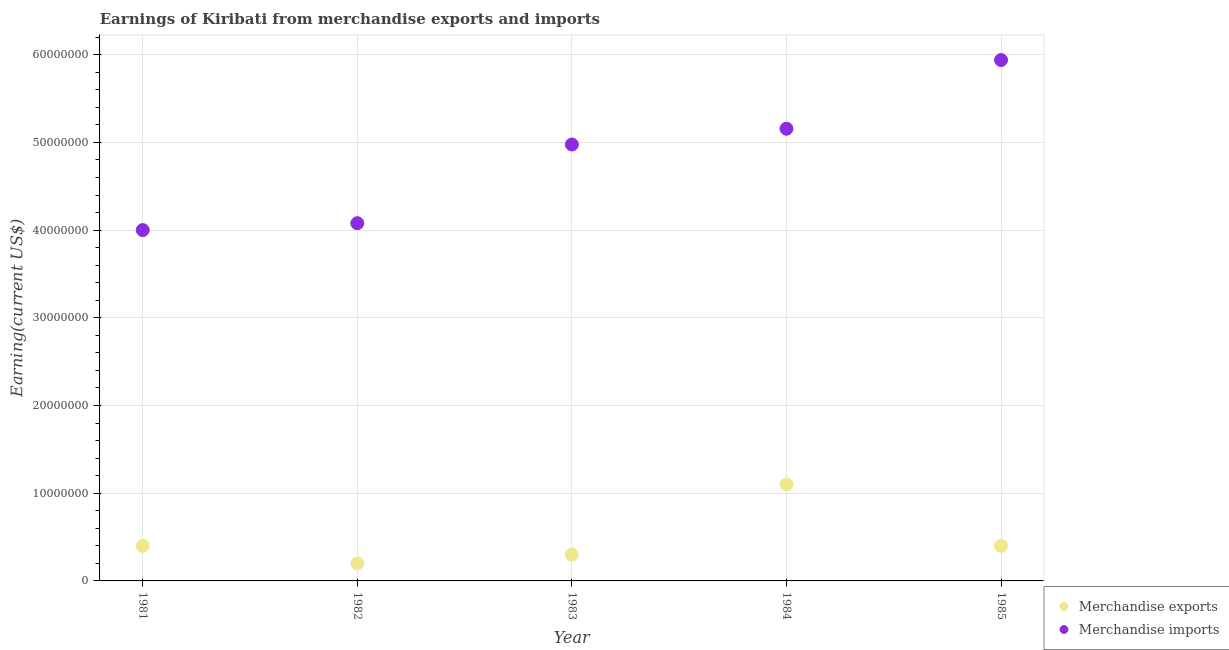How many different coloured dotlines are there?
Your answer should be very brief. 2. What is the earnings from merchandise exports in 1985?
Your answer should be compact. 4.00e+06. Across all years, what is the maximum earnings from merchandise imports?
Keep it short and to the point. 5.94e+07. Across all years, what is the minimum earnings from merchandise exports?
Offer a terse response. 2.00e+06. In which year was the earnings from merchandise exports maximum?
Make the answer very short. 1984. What is the total earnings from merchandise imports in the graph?
Provide a succinct answer. 2.41e+08. What is the difference between the earnings from merchandise imports in 1981 and that in 1983?
Make the answer very short. -9.76e+06. What is the difference between the earnings from merchandise imports in 1985 and the earnings from merchandise exports in 1983?
Offer a very short reply. 5.64e+07. What is the average earnings from merchandise imports per year?
Keep it short and to the point. 4.83e+07. In the year 1982, what is the difference between the earnings from merchandise exports and earnings from merchandise imports?
Your response must be concise. -3.88e+07. What is the ratio of the earnings from merchandise imports in 1981 to that in 1984?
Your answer should be very brief. 0.78. Is the earnings from merchandise exports in 1983 less than that in 1984?
Make the answer very short. Yes. What is the difference between the highest and the lowest earnings from merchandise imports?
Ensure brevity in your answer.  1.94e+07. Does the earnings from merchandise exports monotonically increase over the years?
Your response must be concise. No. Is the earnings from merchandise exports strictly greater than the earnings from merchandise imports over the years?
Offer a very short reply. No. How many dotlines are there?
Your answer should be compact. 2. Does the graph contain any zero values?
Provide a short and direct response. No. Does the graph contain grids?
Your answer should be compact. Yes. How many legend labels are there?
Give a very brief answer. 2. How are the legend labels stacked?
Provide a short and direct response. Vertical. What is the title of the graph?
Provide a short and direct response. Earnings of Kiribati from merchandise exports and imports. What is the label or title of the Y-axis?
Your answer should be compact. Earning(current US$). What is the Earning(current US$) in Merchandise imports in 1981?
Your answer should be compact. 4.00e+07. What is the Earning(current US$) in Merchandise imports in 1982?
Keep it short and to the point. 4.08e+07. What is the Earning(current US$) in Merchandise imports in 1983?
Your answer should be very brief. 4.98e+07. What is the Earning(current US$) in Merchandise exports in 1984?
Your response must be concise. 1.10e+07. What is the Earning(current US$) in Merchandise imports in 1984?
Your answer should be compact. 5.16e+07. What is the Earning(current US$) in Merchandise exports in 1985?
Offer a very short reply. 4.00e+06. What is the Earning(current US$) of Merchandise imports in 1985?
Ensure brevity in your answer.  5.94e+07. Across all years, what is the maximum Earning(current US$) of Merchandise exports?
Keep it short and to the point. 1.10e+07. Across all years, what is the maximum Earning(current US$) in Merchandise imports?
Give a very brief answer. 5.94e+07. Across all years, what is the minimum Earning(current US$) in Merchandise exports?
Your answer should be very brief. 2.00e+06. Across all years, what is the minimum Earning(current US$) in Merchandise imports?
Keep it short and to the point. 4.00e+07. What is the total Earning(current US$) of Merchandise exports in the graph?
Make the answer very short. 2.40e+07. What is the total Earning(current US$) in Merchandise imports in the graph?
Provide a short and direct response. 2.41e+08. What is the difference between the Earning(current US$) in Merchandise imports in 1981 and that in 1982?
Your response must be concise. -7.85e+05. What is the difference between the Earning(current US$) of Merchandise exports in 1981 and that in 1983?
Make the answer very short. 1.00e+06. What is the difference between the Earning(current US$) in Merchandise imports in 1981 and that in 1983?
Your response must be concise. -9.76e+06. What is the difference between the Earning(current US$) of Merchandise exports in 1981 and that in 1984?
Offer a terse response. -7.00e+06. What is the difference between the Earning(current US$) in Merchandise imports in 1981 and that in 1984?
Give a very brief answer. -1.16e+07. What is the difference between the Earning(current US$) in Merchandise imports in 1981 and that in 1985?
Your answer should be very brief. -1.94e+07. What is the difference between the Earning(current US$) of Merchandise imports in 1982 and that in 1983?
Provide a succinct answer. -8.97e+06. What is the difference between the Earning(current US$) in Merchandise exports in 1982 and that in 1984?
Your response must be concise. -9.00e+06. What is the difference between the Earning(current US$) in Merchandise imports in 1982 and that in 1984?
Your response must be concise. -1.08e+07. What is the difference between the Earning(current US$) of Merchandise exports in 1982 and that in 1985?
Keep it short and to the point. -2.00e+06. What is the difference between the Earning(current US$) in Merchandise imports in 1982 and that in 1985?
Your answer should be compact. -1.86e+07. What is the difference between the Earning(current US$) of Merchandise exports in 1983 and that in 1984?
Make the answer very short. -8.00e+06. What is the difference between the Earning(current US$) of Merchandise imports in 1983 and that in 1984?
Your answer should be compact. -1.80e+06. What is the difference between the Earning(current US$) of Merchandise exports in 1983 and that in 1985?
Offer a terse response. -1.00e+06. What is the difference between the Earning(current US$) of Merchandise imports in 1983 and that in 1985?
Your answer should be compact. -9.63e+06. What is the difference between the Earning(current US$) in Merchandise exports in 1984 and that in 1985?
Keep it short and to the point. 7.00e+06. What is the difference between the Earning(current US$) of Merchandise imports in 1984 and that in 1985?
Make the answer very short. -7.83e+06. What is the difference between the Earning(current US$) of Merchandise exports in 1981 and the Earning(current US$) of Merchandise imports in 1982?
Ensure brevity in your answer.  -3.68e+07. What is the difference between the Earning(current US$) of Merchandise exports in 1981 and the Earning(current US$) of Merchandise imports in 1983?
Make the answer very short. -4.58e+07. What is the difference between the Earning(current US$) in Merchandise exports in 1981 and the Earning(current US$) in Merchandise imports in 1984?
Your answer should be compact. -4.76e+07. What is the difference between the Earning(current US$) in Merchandise exports in 1981 and the Earning(current US$) in Merchandise imports in 1985?
Offer a very short reply. -5.54e+07. What is the difference between the Earning(current US$) in Merchandise exports in 1982 and the Earning(current US$) in Merchandise imports in 1983?
Give a very brief answer. -4.78e+07. What is the difference between the Earning(current US$) in Merchandise exports in 1982 and the Earning(current US$) in Merchandise imports in 1984?
Offer a terse response. -4.96e+07. What is the difference between the Earning(current US$) in Merchandise exports in 1982 and the Earning(current US$) in Merchandise imports in 1985?
Your response must be concise. -5.74e+07. What is the difference between the Earning(current US$) of Merchandise exports in 1983 and the Earning(current US$) of Merchandise imports in 1984?
Your response must be concise. -4.86e+07. What is the difference between the Earning(current US$) of Merchandise exports in 1983 and the Earning(current US$) of Merchandise imports in 1985?
Offer a very short reply. -5.64e+07. What is the difference between the Earning(current US$) in Merchandise exports in 1984 and the Earning(current US$) in Merchandise imports in 1985?
Your response must be concise. -4.84e+07. What is the average Earning(current US$) in Merchandise exports per year?
Ensure brevity in your answer.  4.80e+06. What is the average Earning(current US$) of Merchandise imports per year?
Your answer should be compact. 4.83e+07. In the year 1981, what is the difference between the Earning(current US$) in Merchandise exports and Earning(current US$) in Merchandise imports?
Provide a short and direct response. -3.60e+07. In the year 1982, what is the difference between the Earning(current US$) in Merchandise exports and Earning(current US$) in Merchandise imports?
Your answer should be compact. -3.88e+07. In the year 1983, what is the difference between the Earning(current US$) of Merchandise exports and Earning(current US$) of Merchandise imports?
Keep it short and to the point. -4.68e+07. In the year 1984, what is the difference between the Earning(current US$) of Merchandise exports and Earning(current US$) of Merchandise imports?
Make the answer very short. -4.06e+07. In the year 1985, what is the difference between the Earning(current US$) of Merchandise exports and Earning(current US$) of Merchandise imports?
Offer a very short reply. -5.54e+07. What is the ratio of the Earning(current US$) of Merchandise imports in 1981 to that in 1982?
Provide a succinct answer. 0.98. What is the ratio of the Earning(current US$) of Merchandise imports in 1981 to that in 1983?
Offer a very short reply. 0.8. What is the ratio of the Earning(current US$) of Merchandise exports in 1981 to that in 1984?
Keep it short and to the point. 0.36. What is the ratio of the Earning(current US$) in Merchandise imports in 1981 to that in 1984?
Your answer should be compact. 0.78. What is the ratio of the Earning(current US$) of Merchandise exports in 1981 to that in 1985?
Offer a very short reply. 1. What is the ratio of the Earning(current US$) of Merchandise imports in 1981 to that in 1985?
Your answer should be compact. 0.67. What is the ratio of the Earning(current US$) of Merchandise exports in 1982 to that in 1983?
Your response must be concise. 0.67. What is the ratio of the Earning(current US$) of Merchandise imports in 1982 to that in 1983?
Your answer should be very brief. 0.82. What is the ratio of the Earning(current US$) in Merchandise exports in 1982 to that in 1984?
Your response must be concise. 0.18. What is the ratio of the Earning(current US$) of Merchandise imports in 1982 to that in 1984?
Provide a short and direct response. 0.79. What is the ratio of the Earning(current US$) of Merchandise exports in 1982 to that in 1985?
Give a very brief answer. 0.5. What is the ratio of the Earning(current US$) of Merchandise imports in 1982 to that in 1985?
Keep it short and to the point. 0.69. What is the ratio of the Earning(current US$) of Merchandise exports in 1983 to that in 1984?
Keep it short and to the point. 0.27. What is the ratio of the Earning(current US$) of Merchandise imports in 1983 to that in 1984?
Offer a very short reply. 0.97. What is the ratio of the Earning(current US$) of Merchandise exports in 1983 to that in 1985?
Ensure brevity in your answer.  0.75. What is the ratio of the Earning(current US$) of Merchandise imports in 1983 to that in 1985?
Ensure brevity in your answer.  0.84. What is the ratio of the Earning(current US$) of Merchandise exports in 1984 to that in 1985?
Your answer should be compact. 2.75. What is the ratio of the Earning(current US$) in Merchandise imports in 1984 to that in 1985?
Offer a very short reply. 0.87. What is the difference between the highest and the second highest Earning(current US$) in Merchandise exports?
Your response must be concise. 7.00e+06. What is the difference between the highest and the second highest Earning(current US$) of Merchandise imports?
Offer a very short reply. 7.83e+06. What is the difference between the highest and the lowest Earning(current US$) of Merchandise exports?
Provide a short and direct response. 9.00e+06. What is the difference between the highest and the lowest Earning(current US$) in Merchandise imports?
Your answer should be very brief. 1.94e+07. 